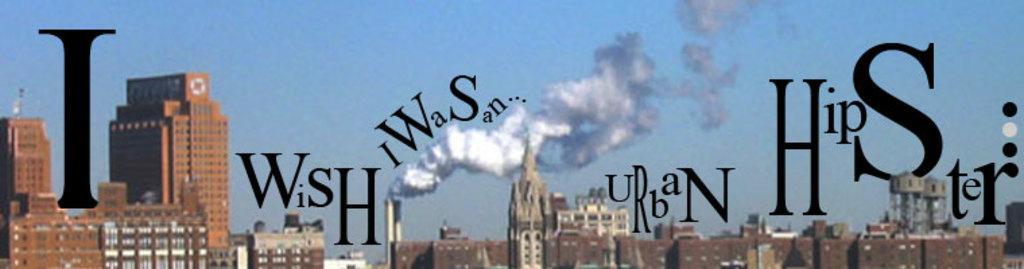Can you describe this image briefly? This is an edited image. In front of the picture, we see some text written as "I wish I was an urban hipster". In the background, we see the buildings in white and brown color. We see the smoke emitted from the industry or a factory. At the top, we see the sky, which is blue in color. 